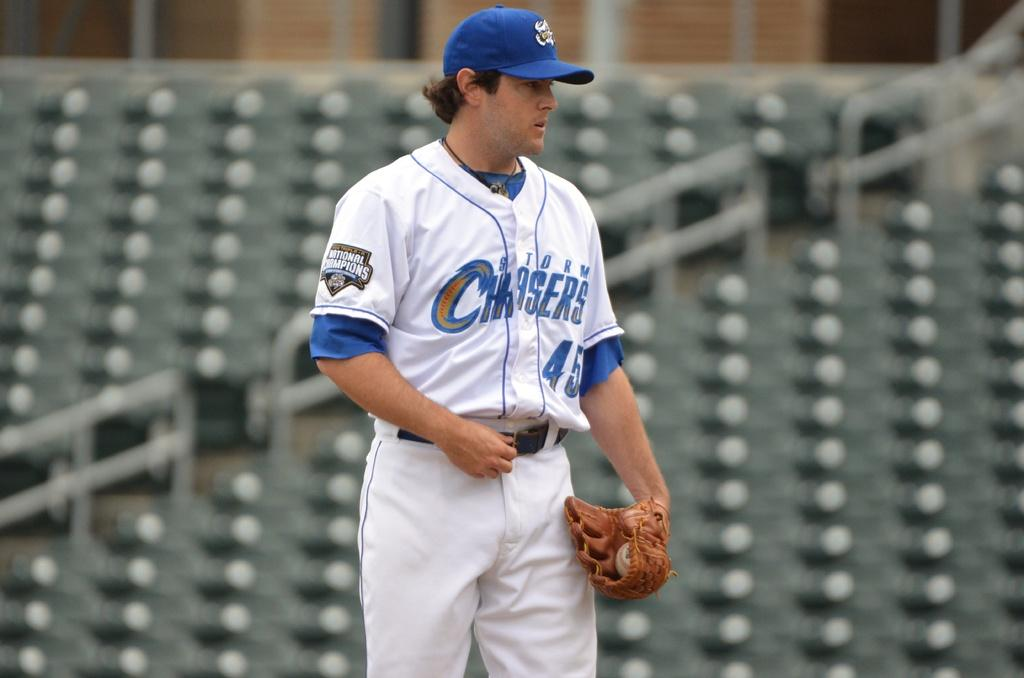<image>
Summarize the visual content of the image. A baseball player whose number is 45 looking down with gloves on his hands 